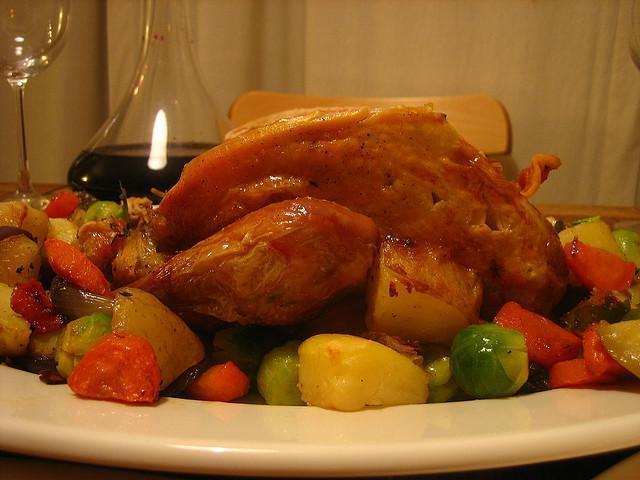How many carrots are in the picture?
Give a very brief answer. 4. 